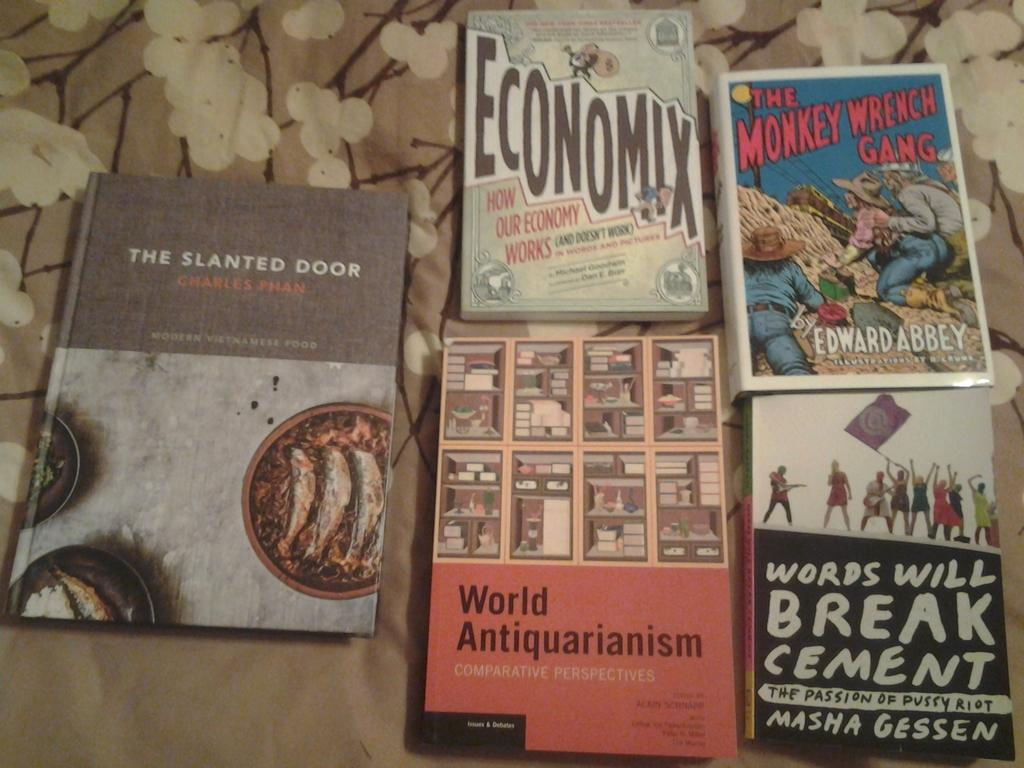<image>
Create a compact narrative representing the image presented. books around one another with one of them titled 'the slanted door' 